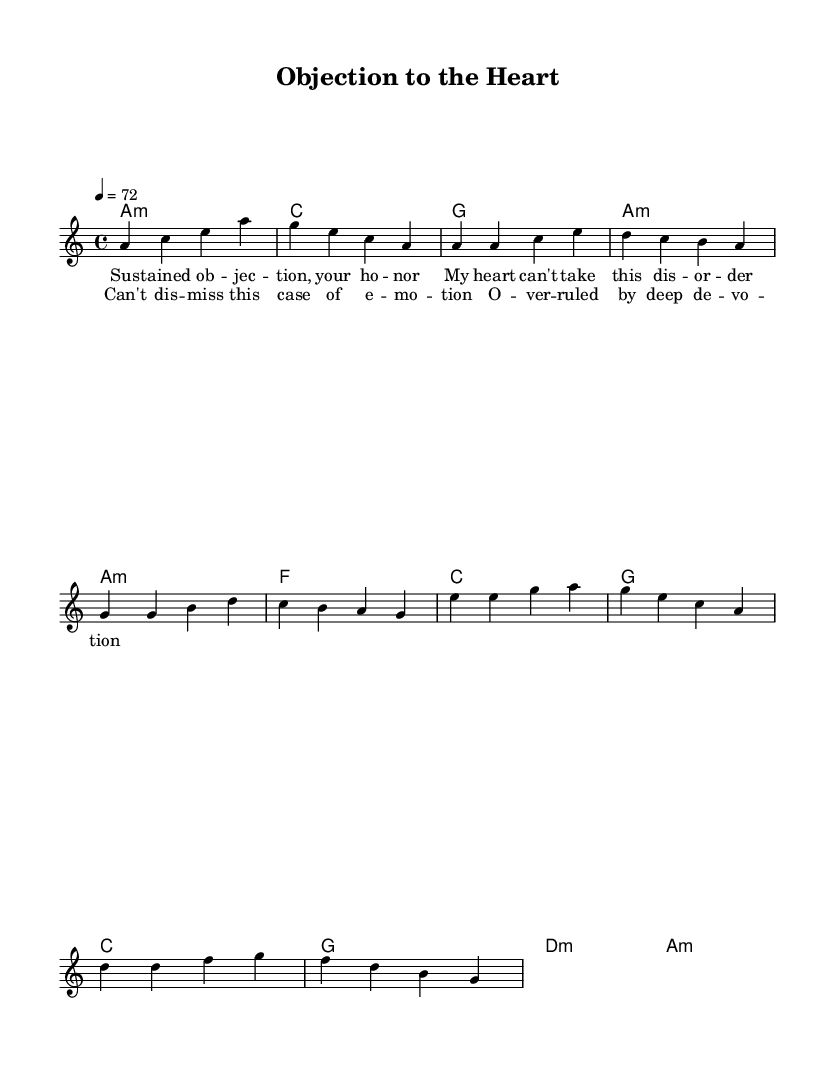What is the key signature of this music? The key signature is indicated by the placement of the notes on the staff and their corresponding accidentals. In this piece, there are no sharps or flats that modify the pitch of the notes, suggesting that it is in the key of A minor.
Answer: A minor What is the time signature of this music? The time signature is found at the beginning of the piece, shown as a fraction. This piece displays a 4/4 time signature, which means there are four beats in each measure and the quarter note gets one beat.
Answer: 4/4 What is the tempo marking of this music? The tempo marking is usually written above the staff, which indicates the speed of the piece. In this score, it states "4 = 72," meaning the quarter note should be played at a pace of 72 beats per minute.
Answer: 72 What is the first chord in the harmonies section? The first chord is indicated at the start of the chord progression. The score shows "a1:m," which refers to an A minor chord.
Answer: A minor Which lyric line represents the chorus? The chorus can be identified as the repeated section of the lyrics in the structure. This section starts with "Can't dis -- miss this case of e -- mo -- tion," which clearly designates it as the chorus section.
Answer: Can't dis -- miss this case of e -- mo -- tion How do the lyrics incorporate legal terminology? The lyrics contain specific terms related to legal proceedings, such as "objection," "your honor," and "case," which evoke a courtroom scenario, and they align with emotional narratives that may resonate in relationships, blending law with personal feelings.
Answer: Legal terminology What is the significance of the emotional narrative in this piece? The emotional narrative connects the legal terms to personal experiences of love and heartache, suggesting that the disputes of the heart can be seen through the lens of legal proceedings, creating a metaphor for emotional struggles reflective in relationships.
Answer: Emotional struggles 